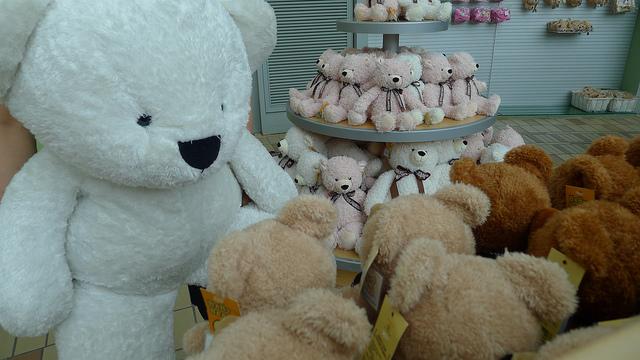Is this a store?
Be succinct. Yes. How many teddy bear's are there?
Quick response, please. Lot. What is pictured?
Short answer required. Teddy bears. Are these old teddy bears?
Concise answer only. No. What is black?
Be succinct. Bear's nose. 